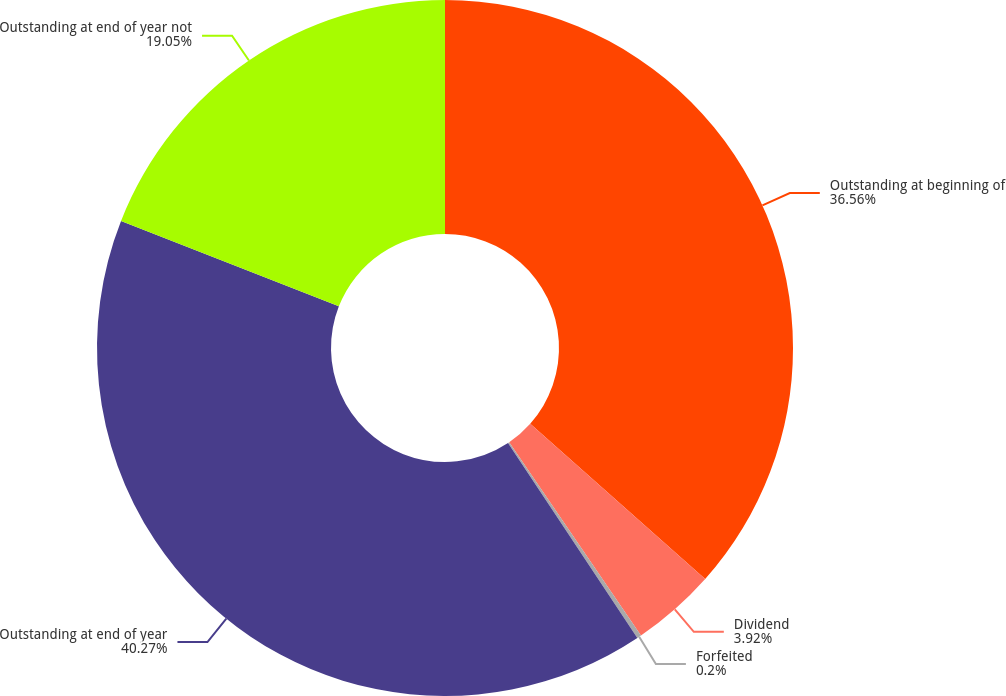Convert chart to OTSL. <chart><loc_0><loc_0><loc_500><loc_500><pie_chart><fcel>Outstanding at beginning of<fcel>Dividend<fcel>Forfeited<fcel>Outstanding at end of year<fcel>Outstanding at end of year not<nl><fcel>36.56%<fcel>3.92%<fcel>0.2%<fcel>40.27%<fcel>19.05%<nl></chart> 